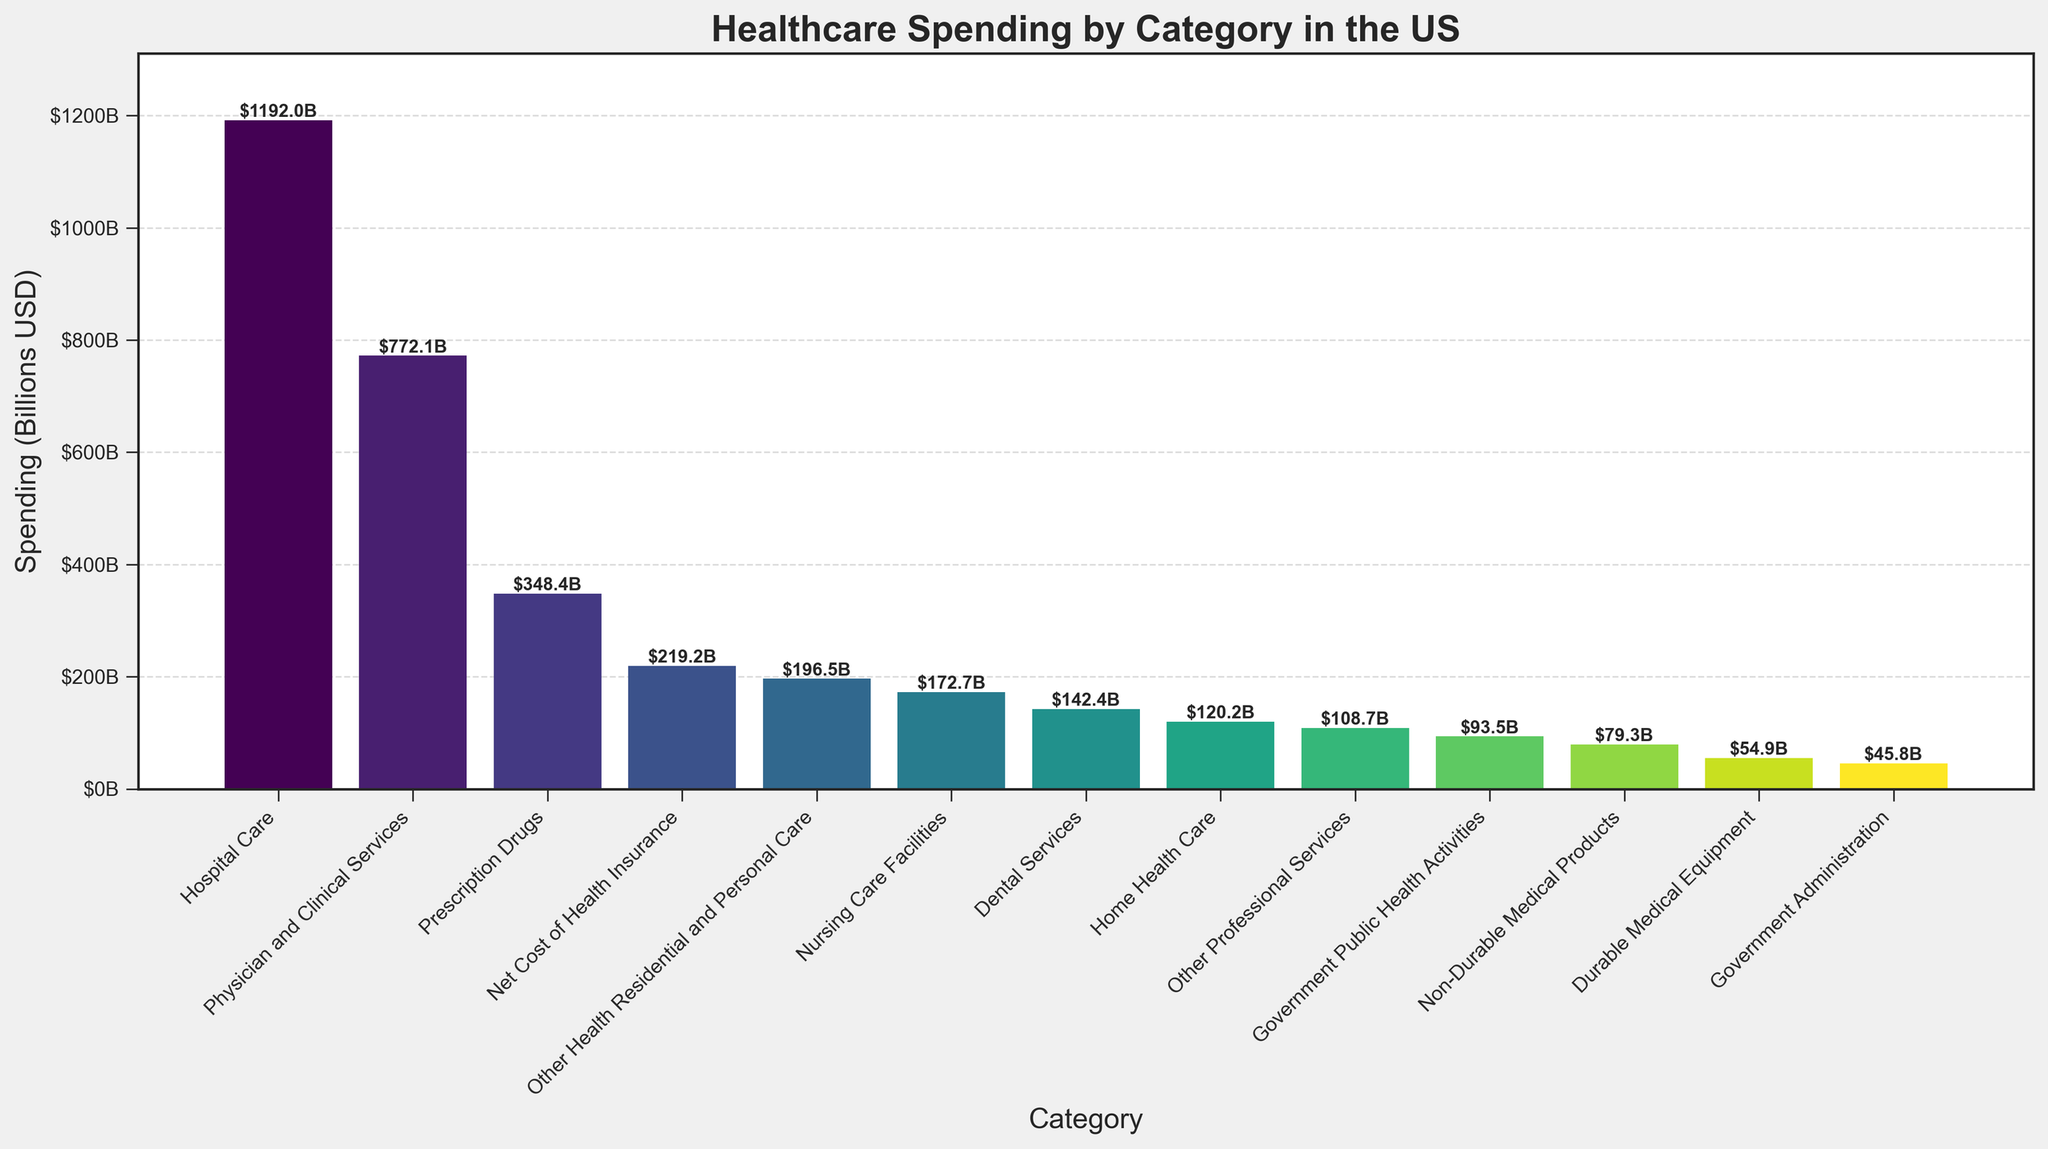How much total spending is depicted in the figure? Sum up all spending categories: 1192.0 + 772.1 + 348.4 + 196.5 + 172.7 + 142.4 + 120.2 + 108.7 + 54.9 + 79.3 + 45.8 + 219.2 + 93.5 = 3545.7 billion USD.
Answer: 3545.7 billion USD What percentage of the total healthcare spending is attributed to Hospital Care? Divide the spending on Hospital Care by the total spending and multiply by 100: (1192.0 / 3545.7) * 100 = 33.6%.
Answer: 33.6% How does spending on Prescription Drugs compare to spending on Hospital Care? Prescription Drugs spending is 348.4 billion USD, whereas Hospital Care spending is 1192.0 billion USD. 348.4 is less than 1192.0.
Answer: Less than Which category has the least spending? Look for the shortest bar in the plot; it corresponds to Government Administration with 45.8 billion USD.
Answer: Government Administration If you combine the spending on Home Health Care, Dental Services, and Nursing Care Facilities, how does it compare to the spending on Physician and Clinical Services? Adding Home Health Care (120.2), Dental Services (142.4), and Nursing Care Facilities (172.7): 120.2 + 142.4 + 172.7 = 435.3 billion USD. Physician and Clinical Services is 772.1 billion USD. 435.3 is less than 772.1.
Answer: Less than What is the median value of the spending categories? Arrange the spending values in ascending order and find the middle value: 45.8, 54.9, 79.3, 93.5, 108.7, 120.2, 142.4, 172.7, 196.5, 219.2, 348.4, 772.1, 1192.0. The median is the middle value, 142.4 billion USD (Dental Services).
Answer: 142.4 billion USD Which spending category is closest to the average spending? Calculate the average: Total spending is 3545.7 billion USD; there are 13 categories. 3545.7 / 13 = 272.7 billion USD. The closest value is Net Cost of Health Insurance (219.2 billion USD) or Other Health Residential and Personal Care (196.5 billion USD). By difference, Net Cost of Health Insurance is closer: (272.7 - 219.2) = 53.5, and (272.7 - 196.5) = 76.2.
Answer: Net Cost of Health Insurance Compare the spending on Durable Medical Equipment to Non-Durable Medical Products. Durable Medical Equipment is 54.9 billion USD, and Non-Durable Medical Products is 79.3 billion USD. 54.9 is less than 79.3.
Answer: Less than 